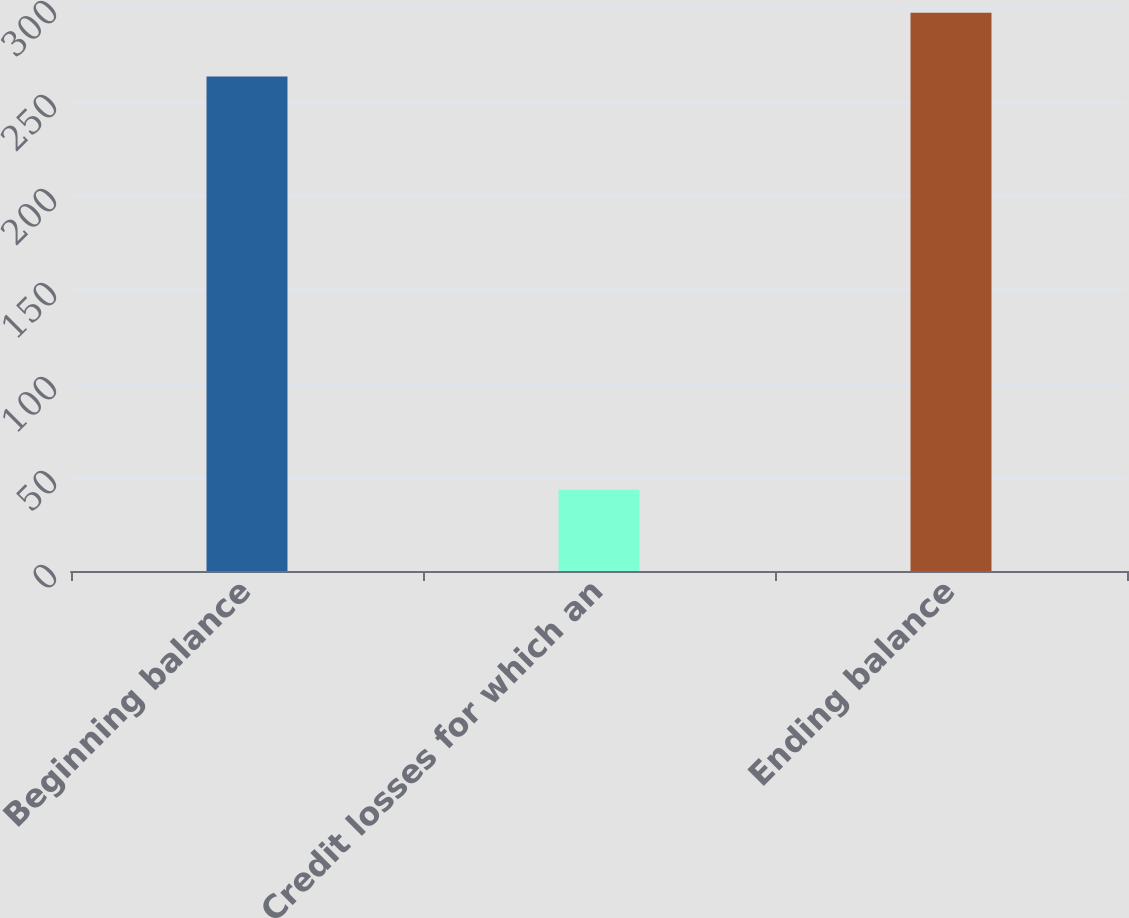<chart> <loc_0><loc_0><loc_500><loc_500><bar_chart><fcel>Beginning balance<fcel>Credit losses for which an<fcel>Ending balance<nl><fcel>263<fcel>43.2<fcel>297<nl></chart> 